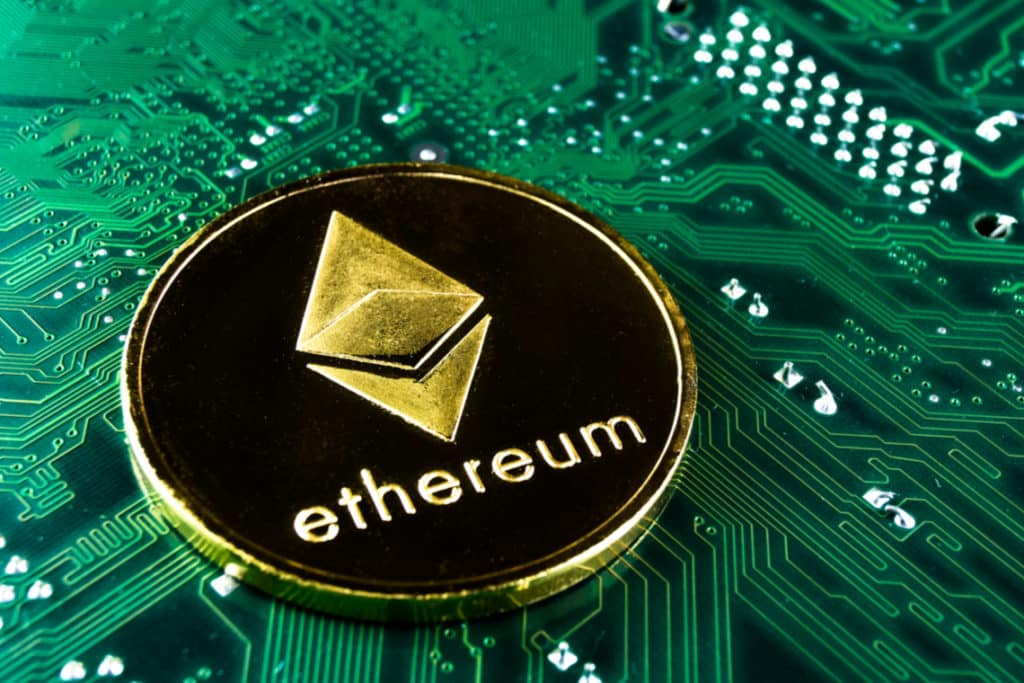Imagine this image represents a historical turning point. What event could it signify? If this image represents a historical turning point, it could signify the moment when cryptocurrencies like Ethereum gained mainstream acceptance and fundamentally altered the global financial landscape. This event could mark the transition from traditional banking and centralized financial institutions to a decentralized economy powered by blockchain technology. It might denote the advent of widespread adoption of digital currency for everyday transactions, international trade, and financial services, where efficiency, transparency, and security reached unprecedented levels. This turning point could further symbolize the decline of fiat currency dominance and the emergence of a new era where digital assets play a pivotal role in economic systems worldwide. 